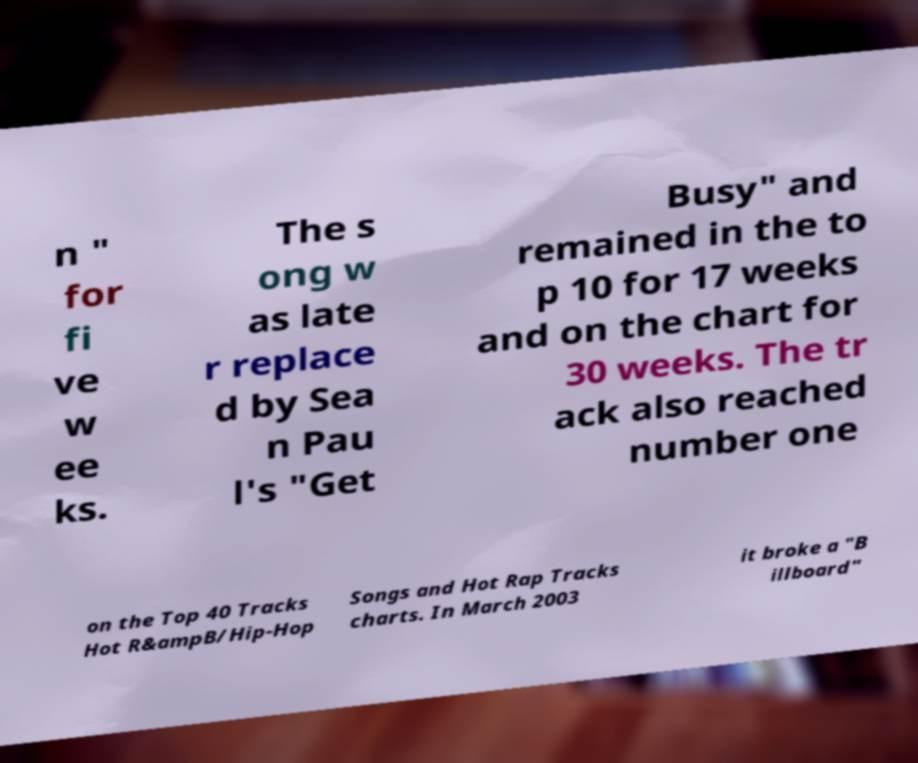What messages or text are displayed in this image? I need them in a readable, typed format. n " for fi ve w ee ks. The s ong w as late r replace d by Sea n Pau l's "Get Busy" and remained in the to p 10 for 17 weeks and on the chart for 30 weeks. The tr ack also reached number one on the Top 40 Tracks Hot R&ampB/Hip-Hop Songs and Hot Rap Tracks charts. In March 2003 it broke a "B illboard" 